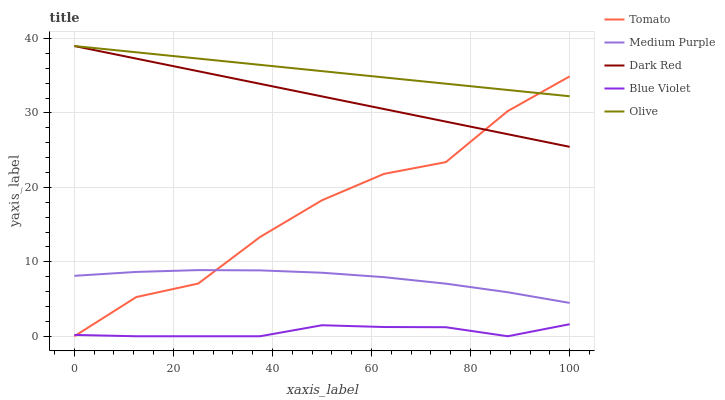Does Blue Violet have the minimum area under the curve?
Answer yes or no. Yes. Does Olive have the maximum area under the curve?
Answer yes or no. Yes. Does Medium Purple have the minimum area under the curve?
Answer yes or no. No. Does Medium Purple have the maximum area under the curve?
Answer yes or no. No. Is Dark Red the smoothest?
Answer yes or no. Yes. Is Tomato the roughest?
Answer yes or no. Yes. Is Medium Purple the smoothest?
Answer yes or no. No. Is Medium Purple the roughest?
Answer yes or no. No. Does Tomato have the lowest value?
Answer yes or no. Yes. Does Medium Purple have the lowest value?
Answer yes or no. No. Does Dark Red have the highest value?
Answer yes or no. Yes. Does Medium Purple have the highest value?
Answer yes or no. No. Is Medium Purple less than Olive?
Answer yes or no. Yes. Is Dark Red greater than Blue Violet?
Answer yes or no. Yes. Does Tomato intersect Olive?
Answer yes or no. Yes. Is Tomato less than Olive?
Answer yes or no. No. Is Tomato greater than Olive?
Answer yes or no. No. Does Medium Purple intersect Olive?
Answer yes or no. No. 